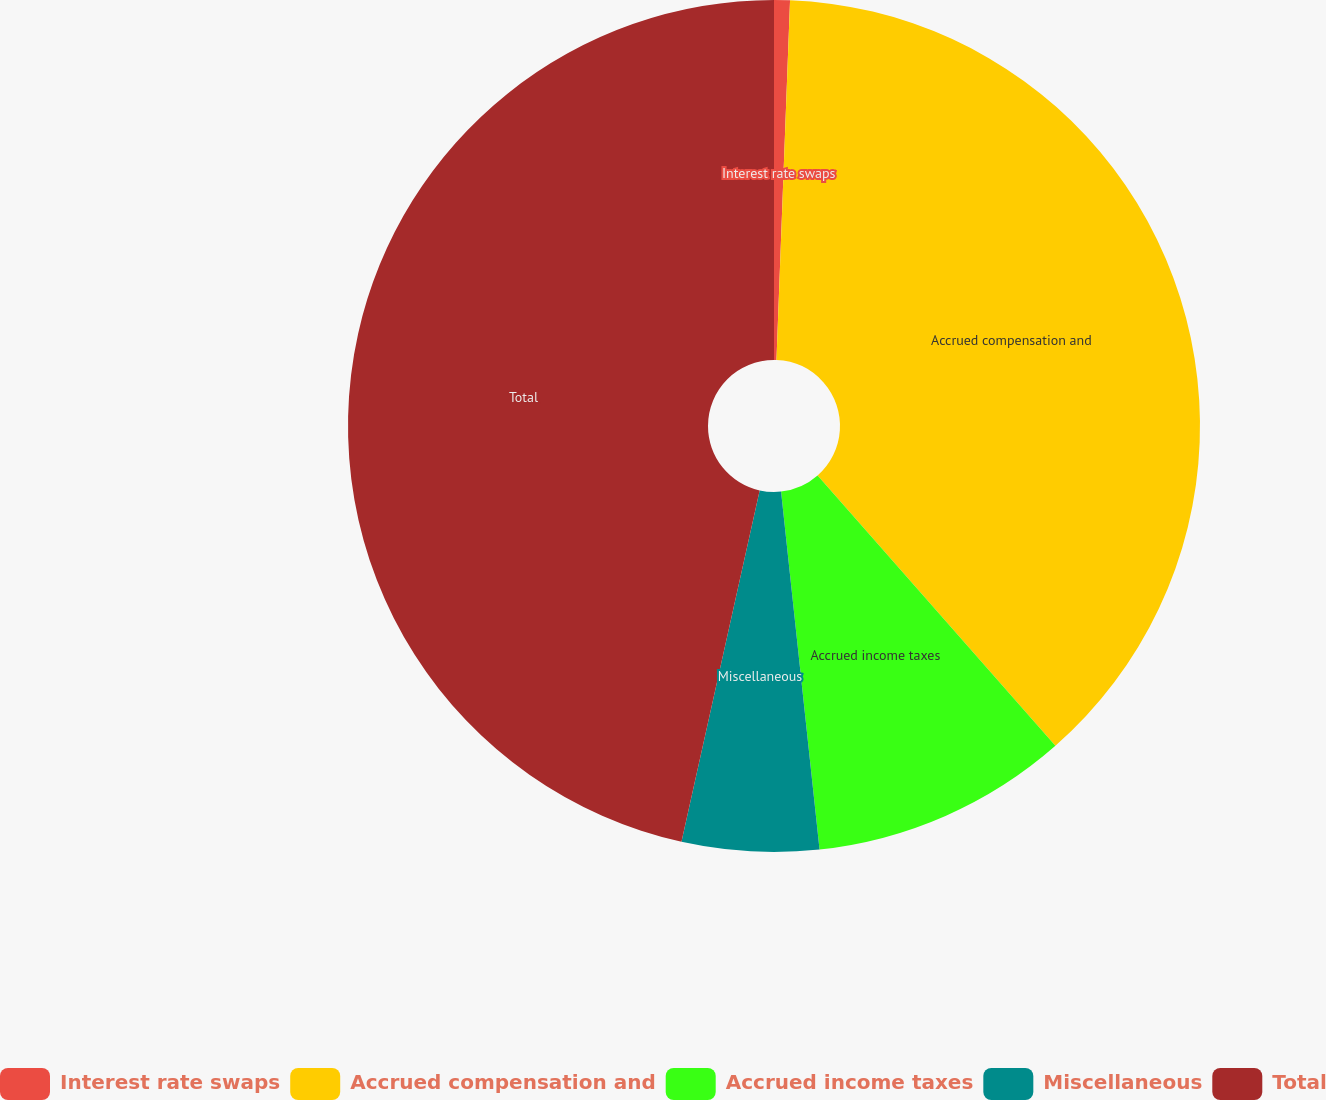<chart> <loc_0><loc_0><loc_500><loc_500><pie_chart><fcel>Interest rate swaps<fcel>Accrued compensation and<fcel>Accrued income taxes<fcel>Miscellaneous<fcel>Total<nl><fcel>0.6%<fcel>37.92%<fcel>9.78%<fcel>5.19%<fcel>46.52%<nl></chart> 